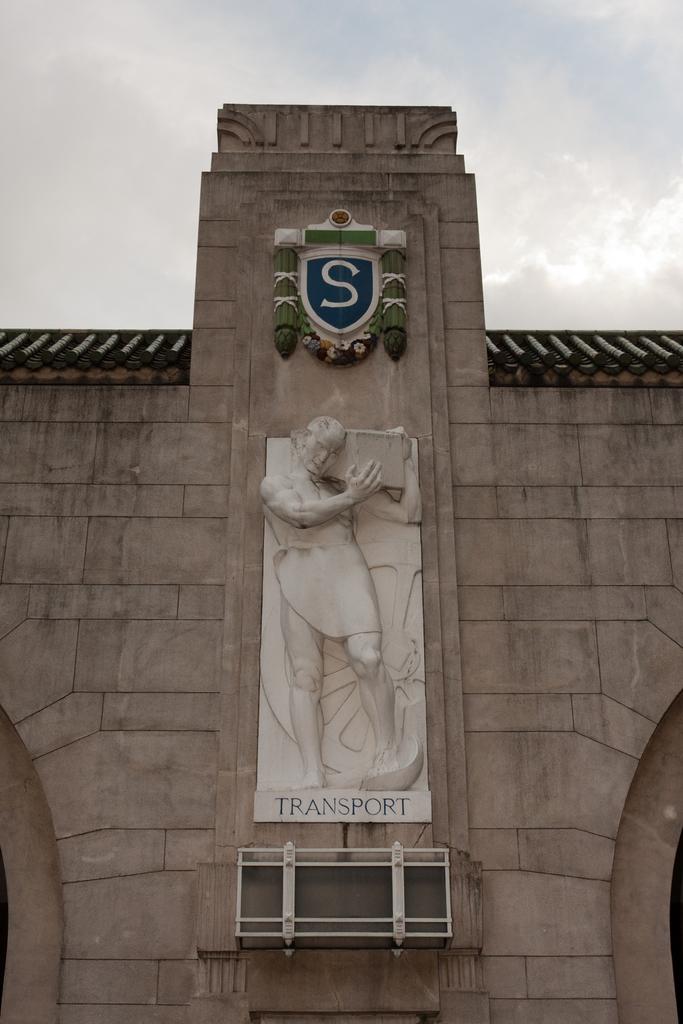What is the single word underneath the statue?
Ensure brevity in your answer.  Transport. 